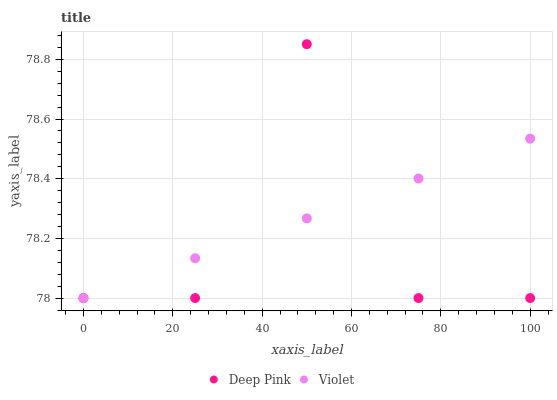Does Deep Pink have the minimum area under the curve?
Answer yes or no. Yes. Does Violet have the maximum area under the curve?
Answer yes or no. Yes. Does Violet have the minimum area under the curve?
Answer yes or no. No. Is Violet the smoothest?
Answer yes or no. Yes. Is Deep Pink the roughest?
Answer yes or no. Yes. Is Violet the roughest?
Answer yes or no. No. Does Deep Pink have the lowest value?
Answer yes or no. Yes. Does Deep Pink have the highest value?
Answer yes or no. Yes. Does Violet have the highest value?
Answer yes or no. No. Does Deep Pink intersect Violet?
Answer yes or no. Yes. Is Deep Pink less than Violet?
Answer yes or no. No. Is Deep Pink greater than Violet?
Answer yes or no. No. 